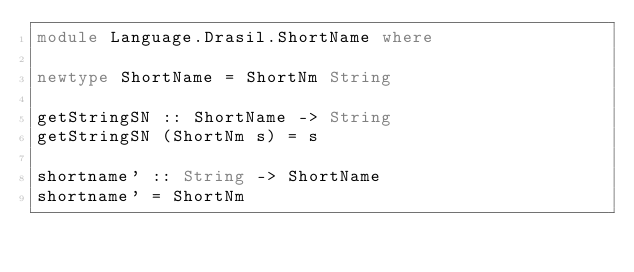Convert code to text. <code><loc_0><loc_0><loc_500><loc_500><_Haskell_>module Language.Drasil.ShortName where

newtype ShortName = ShortNm String

getStringSN :: ShortName -> String
getStringSN (ShortNm s) = s

shortname' :: String -> ShortName
shortname' = ShortNm
</code> 